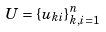<formula> <loc_0><loc_0><loc_500><loc_500>U = \{ u _ { k i } \} _ { k , i = 1 } ^ { n }</formula> 